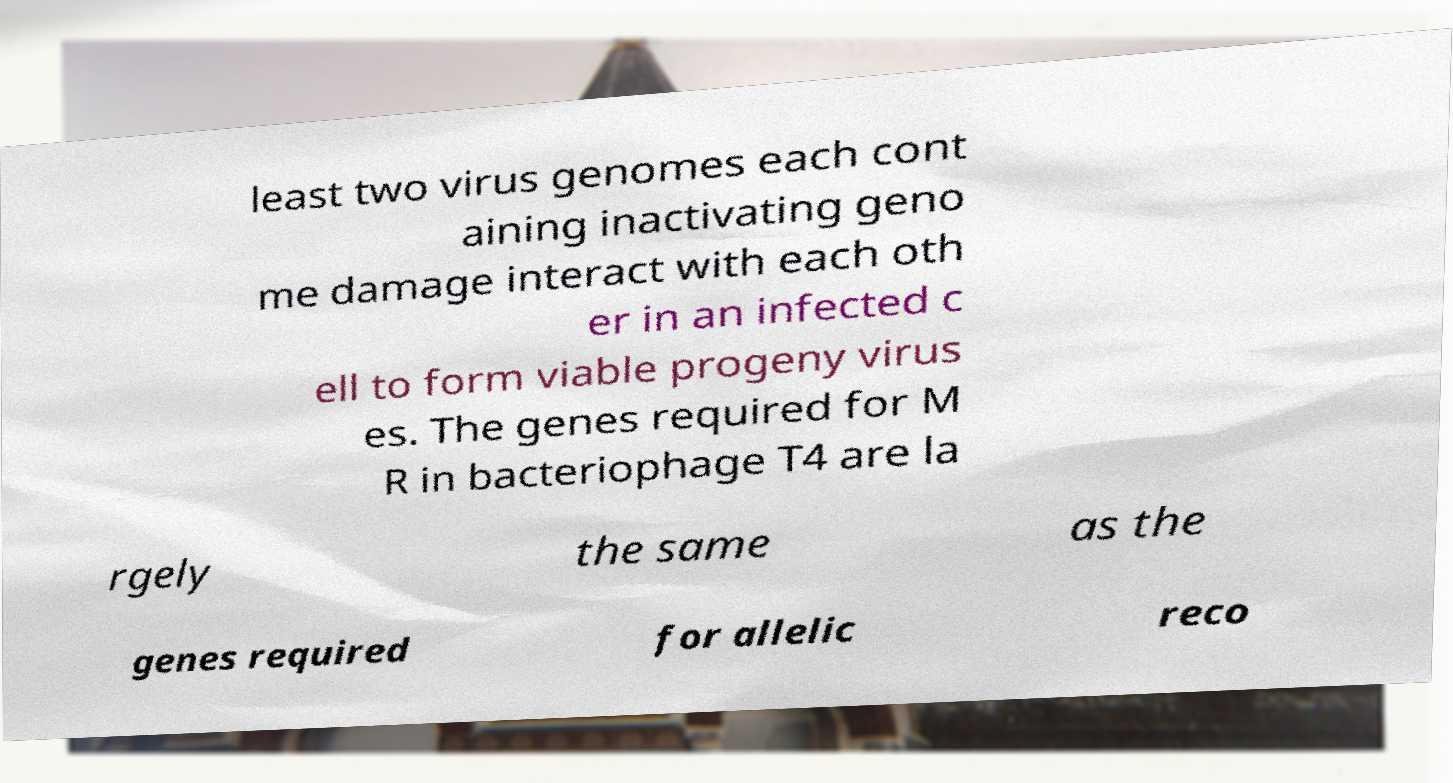Can you read and provide the text displayed in the image?This photo seems to have some interesting text. Can you extract and type it out for me? least two virus genomes each cont aining inactivating geno me damage interact with each oth er in an infected c ell to form viable progeny virus es. The genes required for M R in bacteriophage T4 are la rgely the same as the genes required for allelic reco 